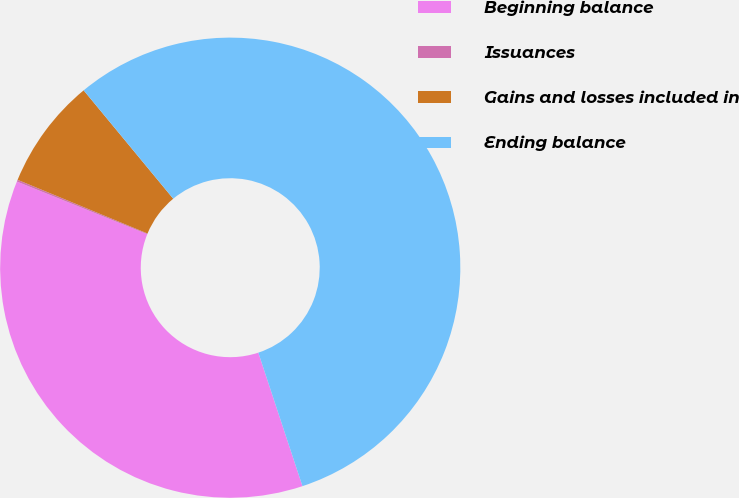Convert chart. <chart><loc_0><loc_0><loc_500><loc_500><pie_chart><fcel>Beginning balance<fcel>Issuances<fcel>Gains and losses included in<fcel>Ending balance<nl><fcel>36.19%<fcel>0.13%<fcel>7.77%<fcel>55.91%<nl></chart> 